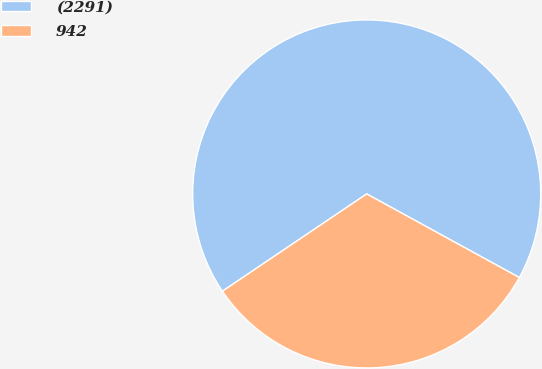Convert chart to OTSL. <chart><loc_0><loc_0><loc_500><loc_500><pie_chart><fcel>(2291)<fcel>942<nl><fcel>67.42%<fcel>32.58%<nl></chart> 